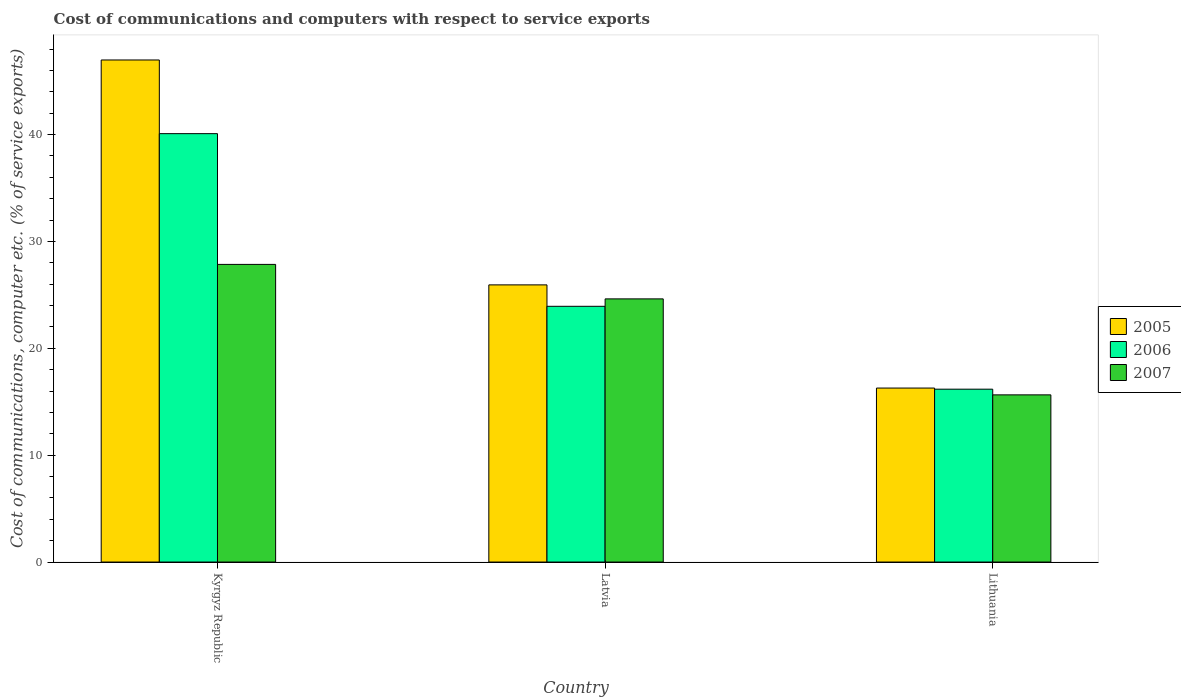How many groups of bars are there?
Offer a terse response. 3. Are the number of bars per tick equal to the number of legend labels?
Your answer should be compact. Yes. Are the number of bars on each tick of the X-axis equal?
Offer a very short reply. Yes. How many bars are there on the 2nd tick from the left?
Offer a very short reply. 3. How many bars are there on the 1st tick from the right?
Ensure brevity in your answer.  3. What is the label of the 1st group of bars from the left?
Offer a terse response. Kyrgyz Republic. What is the cost of communications and computers in 2005 in Lithuania?
Your response must be concise. 16.28. Across all countries, what is the maximum cost of communications and computers in 2005?
Ensure brevity in your answer.  46.98. Across all countries, what is the minimum cost of communications and computers in 2007?
Provide a succinct answer. 15.64. In which country was the cost of communications and computers in 2007 maximum?
Offer a terse response. Kyrgyz Republic. In which country was the cost of communications and computers in 2007 minimum?
Make the answer very short. Lithuania. What is the total cost of communications and computers in 2006 in the graph?
Make the answer very short. 80.19. What is the difference between the cost of communications and computers in 2006 in Kyrgyz Republic and that in Latvia?
Your answer should be compact. 16.16. What is the difference between the cost of communications and computers in 2005 in Kyrgyz Republic and the cost of communications and computers in 2006 in Latvia?
Your answer should be very brief. 23.05. What is the average cost of communications and computers in 2005 per country?
Provide a succinct answer. 29.73. What is the difference between the cost of communications and computers of/in 2007 and cost of communications and computers of/in 2006 in Lithuania?
Your response must be concise. -0.53. In how many countries, is the cost of communications and computers in 2007 greater than 22 %?
Give a very brief answer. 2. What is the ratio of the cost of communications and computers in 2005 in Latvia to that in Lithuania?
Offer a terse response. 1.59. Is the cost of communications and computers in 2005 in Kyrgyz Republic less than that in Latvia?
Offer a terse response. No. What is the difference between the highest and the second highest cost of communications and computers in 2007?
Provide a short and direct response. -3.23. What is the difference between the highest and the lowest cost of communications and computers in 2007?
Provide a succinct answer. 12.21. In how many countries, is the cost of communications and computers in 2006 greater than the average cost of communications and computers in 2006 taken over all countries?
Your response must be concise. 1. Is it the case that in every country, the sum of the cost of communications and computers in 2005 and cost of communications and computers in 2007 is greater than the cost of communications and computers in 2006?
Give a very brief answer. Yes. How many bars are there?
Your response must be concise. 9. Are the values on the major ticks of Y-axis written in scientific E-notation?
Ensure brevity in your answer.  No. Does the graph contain grids?
Your answer should be very brief. No. Where does the legend appear in the graph?
Keep it short and to the point. Center right. How many legend labels are there?
Your answer should be very brief. 3. What is the title of the graph?
Make the answer very short. Cost of communications and computers with respect to service exports. Does "2012" appear as one of the legend labels in the graph?
Your response must be concise. No. What is the label or title of the X-axis?
Give a very brief answer. Country. What is the label or title of the Y-axis?
Keep it short and to the point. Cost of communications, computer etc. (% of service exports). What is the Cost of communications, computer etc. (% of service exports) of 2005 in Kyrgyz Republic?
Your response must be concise. 46.98. What is the Cost of communications, computer etc. (% of service exports) of 2006 in Kyrgyz Republic?
Your answer should be compact. 40.09. What is the Cost of communications, computer etc. (% of service exports) in 2007 in Kyrgyz Republic?
Offer a very short reply. 27.85. What is the Cost of communications, computer etc. (% of service exports) in 2005 in Latvia?
Offer a terse response. 25.94. What is the Cost of communications, computer etc. (% of service exports) of 2006 in Latvia?
Your answer should be compact. 23.93. What is the Cost of communications, computer etc. (% of service exports) in 2007 in Latvia?
Your answer should be very brief. 24.62. What is the Cost of communications, computer etc. (% of service exports) of 2005 in Lithuania?
Offer a very short reply. 16.28. What is the Cost of communications, computer etc. (% of service exports) of 2006 in Lithuania?
Provide a succinct answer. 16.18. What is the Cost of communications, computer etc. (% of service exports) in 2007 in Lithuania?
Ensure brevity in your answer.  15.64. Across all countries, what is the maximum Cost of communications, computer etc. (% of service exports) of 2005?
Your response must be concise. 46.98. Across all countries, what is the maximum Cost of communications, computer etc. (% of service exports) of 2006?
Your answer should be very brief. 40.09. Across all countries, what is the maximum Cost of communications, computer etc. (% of service exports) of 2007?
Provide a short and direct response. 27.85. Across all countries, what is the minimum Cost of communications, computer etc. (% of service exports) of 2005?
Provide a short and direct response. 16.28. Across all countries, what is the minimum Cost of communications, computer etc. (% of service exports) in 2006?
Offer a terse response. 16.18. Across all countries, what is the minimum Cost of communications, computer etc. (% of service exports) of 2007?
Offer a terse response. 15.64. What is the total Cost of communications, computer etc. (% of service exports) in 2005 in the graph?
Keep it short and to the point. 89.2. What is the total Cost of communications, computer etc. (% of service exports) in 2006 in the graph?
Keep it short and to the point. 80.19. What is the total Cost of communications, computer etc. (% of service exports) in 2007 in the graph?
Offer a very short reply. 68.12. What is the difference between the Cost of communications, computer etc. (% of service exports) of 2005 in Kyrgyz Republic and that in Latvia?
Your answer should be compact. 21.05. What is the difference between the Cost of communications, computer etc. (% of service exports) of 2006 in Kyrgyz Republic and that in Latvia?
Provide a succinct answer. 16.16. What is the difference between the Cost of communications, computer etc. (% of service exports) of 2007 in Kyrgyz Republic and that in Latvia?
Your answer should be compact. 3.23. What is the difference between the Cost of communications, computer etc. (% of service exports) of 2005 in Kyrgyz Republic and that in Lithuania?
Make the answer very short. 30.7. What is the difference between the Cost of communications, computer etc. (% of service exports) of 2006 in Kyrgyz Republic and that in Lithuania?
Give a very brief answer. 23.91. What is the difference between the Cost of communications, computer etc. (% of service exports) in 2007 in Kyrgyz Republic and that in Lithuania?
Make the answer very short. 12.21. What is the difference between the Cost of communications, computer etc. (% of service exports) in 2005 in Latvia and that in Lithuania?
Offer a terse response. 9.66. What is the difference between the Cost of communications, computer etc. (% of service exports) of 2006 in Latvia and that in Lithuania?
Provide a succinct answer. 7.76. What is the difference between the Cost of communications, computer etc. (% of service exports) of 2007 in Latvia and that in Lithuania?
Give a very brief answer. 8.98. What is the difference between the Cost of communications, computer etc. (% of service exports) of 2005 in Kyrgyz Republic and the Cost of communications, computer etc. (% of service exports) of 2006 in Latvia?
Offer a terse response. 23.05. What is the difference between the Cost of communications, computer etc. (% of service exports) in 2005 in Kyrgyz Republic and the Cost of communications, computer etc. (% of service exports) in 2007 in Latvia?
Your answer should be very brief. 22.36. What is the difference between the Cost of communications, computer etc. (% of service exports) of 2006 in Kyrgyz Republic and the Cost of communications, computer etc. (% of service exports) of 2007 in Latvia?
Ensure brevity in your answer.  15.46. What is the difference between the Cost of communications, computer etc. (% of service exports) of 2005 in Kyrgyz Republic and the Cost of communications, computer etc. (% of service exports) of 2006 in Lithuania?
Ensure brevity in your answer.  30.81. What is the difference between the Cost of communications, computer etc. (% of service exports) of 2005 in Kyrgyz Republic and the Cost of communications, computer etc. (% of service exports) of 2007 in Lithuania?
Offer a terse response. 31.34. What is the difference between the Cost of communications, computer etc. (% of service exports) of 2006 in Kyrgyz Republic and the Cost of communications, computer etc. (% of service exports) of 2007 in Lithuania?
Your answer should be very brief. 24.44. What is the difference between the Cost of communications, computer etc. (% of service exports) of 2005 in Latvia and the Cost of communications, computer etc. (% of service exports) of 2006 in Lithuania?
Offer a terse response. 9.76. What is the difference between the Cost of communications, computer etc. (% of service exports) of 2005 in Latvia and the Cost of communications, computer etc. (% of service exports) of 2007 in Lithuania?
Your answer should be very brief. 10.29. What is the difference between the Cost of communications, computer etc. (% of service exports) in 2006 in Latvia and the Cost of communications, computer etc. (% of service exports) in 2007 in Lithuania?
Your response must be concise. 8.29. What is the average Cost of communications, computer etc. (% of service exports) in 2005 per country?
Provide a short and direct response. 29.73. What is the average Cost of communications, computer etc. (% of service exports) of 2006 per country?
Provide a short and direct response. 26.73. What is the average Cost of communications, computer etc. (% of service exports) of 2007 per country?
Make the answer very short. 22.71. What is the difference between the Cost of communications, computer etc. (% of service exports) in 2005 and Cost of communications, computer etc. (% of service exports) in 2006 in Kyrgyz Republic?
Keep it short and to the point. 6.89. What is the difference between the Cost of communications, computer etc. (% of service exports) of 2005 and Cost of communications, computer etc. (% of service exports) of 2007 in Kyrgyz Republic?
Your answer should be compact. 19.13. What is the difference between the Cost of communications, computer etc. (% of service exports) in 2006 and Cost of communications, computer etc. (% of service exports) in 2007 in Kyrgyz Republic?
Make the answer very short. 12.23. What is the difference between the Cost of communications, computer etc. (% of service exports) of 2005 and Cost of communications, computer etc. (% of service exports) of 2006 in Latvia?
Give a very brief answer. 2. What is the difference between the Cost of communications, computer etc. (% of service exports) of 2005 and Cost of communications, computer etc. (% of service exports) of 2007 in Latvia?
Make the answer very short. 1.31. What is the difference between the Cost of communications, computer etc. (% of service exports) of 2006 and Cost of communications, computer etc. (% of service exports) of 2007 in Latvia?
Your answer should be compact. -0.69. What is the difference between the Cost of communications, computer etc. (% of service exports) in 2005 and Cost of communications, computer etc. (% of service exports) in 2006 in Lithuania?
Provide a short and direct response. 0.1. What is the difference between the Cost of communications, computer etc. (% of service exports) of 2005 and Cost of communications, computer etc. (% of service exports) of 2007 in Lithuania?
Give a very brief answer. 0.64. What is the difference between the Cost of communications, computer etc. (% of service exports) of 2006 and Cost of communications, computer etc. (% of service exports) of 2007 in Lithuania?
Make the answer very short. 0.53. What is the ratio of the Cost of communications, computer etc. (% of service exports) in 2005 in Kyrgyz Republic to that in Latvia?
Keep it short and to the point. 1.81. What is the ratio of the Cost of communications, computer etc. (% of service exports) of 2006 in Kyrgyz Republic to that in Latvia?
Offer a very short reply. 1.68. What is the ratio of the Cost of communications, computer etc. (% of service exports) in 2007 in Kyrgyz Republic to that in Latvia?
Make the answer very short. 1.13. What is the ratio of the Cost of communications, computer etc. (% of service exports) of 2005 in Kyrgyz Republic to that in Lithuania?
Provide a succinct answer. 2.89. What is the ratio of the Cost of communications, computer etc. (% of service exports) in 2006 in Kyrgyz Republic to that in Lithuania?
Offer a terse response. 2.48. What is the ratio of the Cost of communications, computer etc. (% of service exports) in 2007 in Kyrgyz Republic to that in Lithuania?
Offer a very short reply. 1.78. What is the ratio of the Cost of communications, computer etc. (% of service exports) of 2005 in Latvia to that in Lithuania?
Offer a terse response. 1.59. What is the ratio of the Cost of communications, computer etc. (% of service exports) of 2006 in Latvia to that in Lithuania?
Offer a very short reply. 1.48. What is the ratio of the Cost of communications, computer etc. (% of service exports) in 2007 in Latvia to that in Lithuania?
Offer a terse response. 1.57. What is the difference between the highest and the second highest Cost of communications, computer etc. (% of service exports) in 2005?
Your answer should be very brief. 21.05. What is the difference between the highest and the second highest Cost of communications, computer etc. (% of service exports) of 2006?
Give a very brief answer. 16.16. What is the difference between the highest and the second highest Cost of communications, computer etc. (% of service exports) in 2007?
Give a very brief answer. 3.23. What is the difference between the highest and the lowest Cost of communications, computer etc. (% of service exports) in 2005?
Ensure brevity in your answer.  30.7. What is the difference between the highest and the lowest Cost of communications, computer etc. (% of service exports) in 2006?
Ensure brevity in your answer.  23.91. What is the difference between the highest and the lowest Cost of communications, computer etc. (% of service exports) of 2007?
Provide a succinct answer. 12.21. 